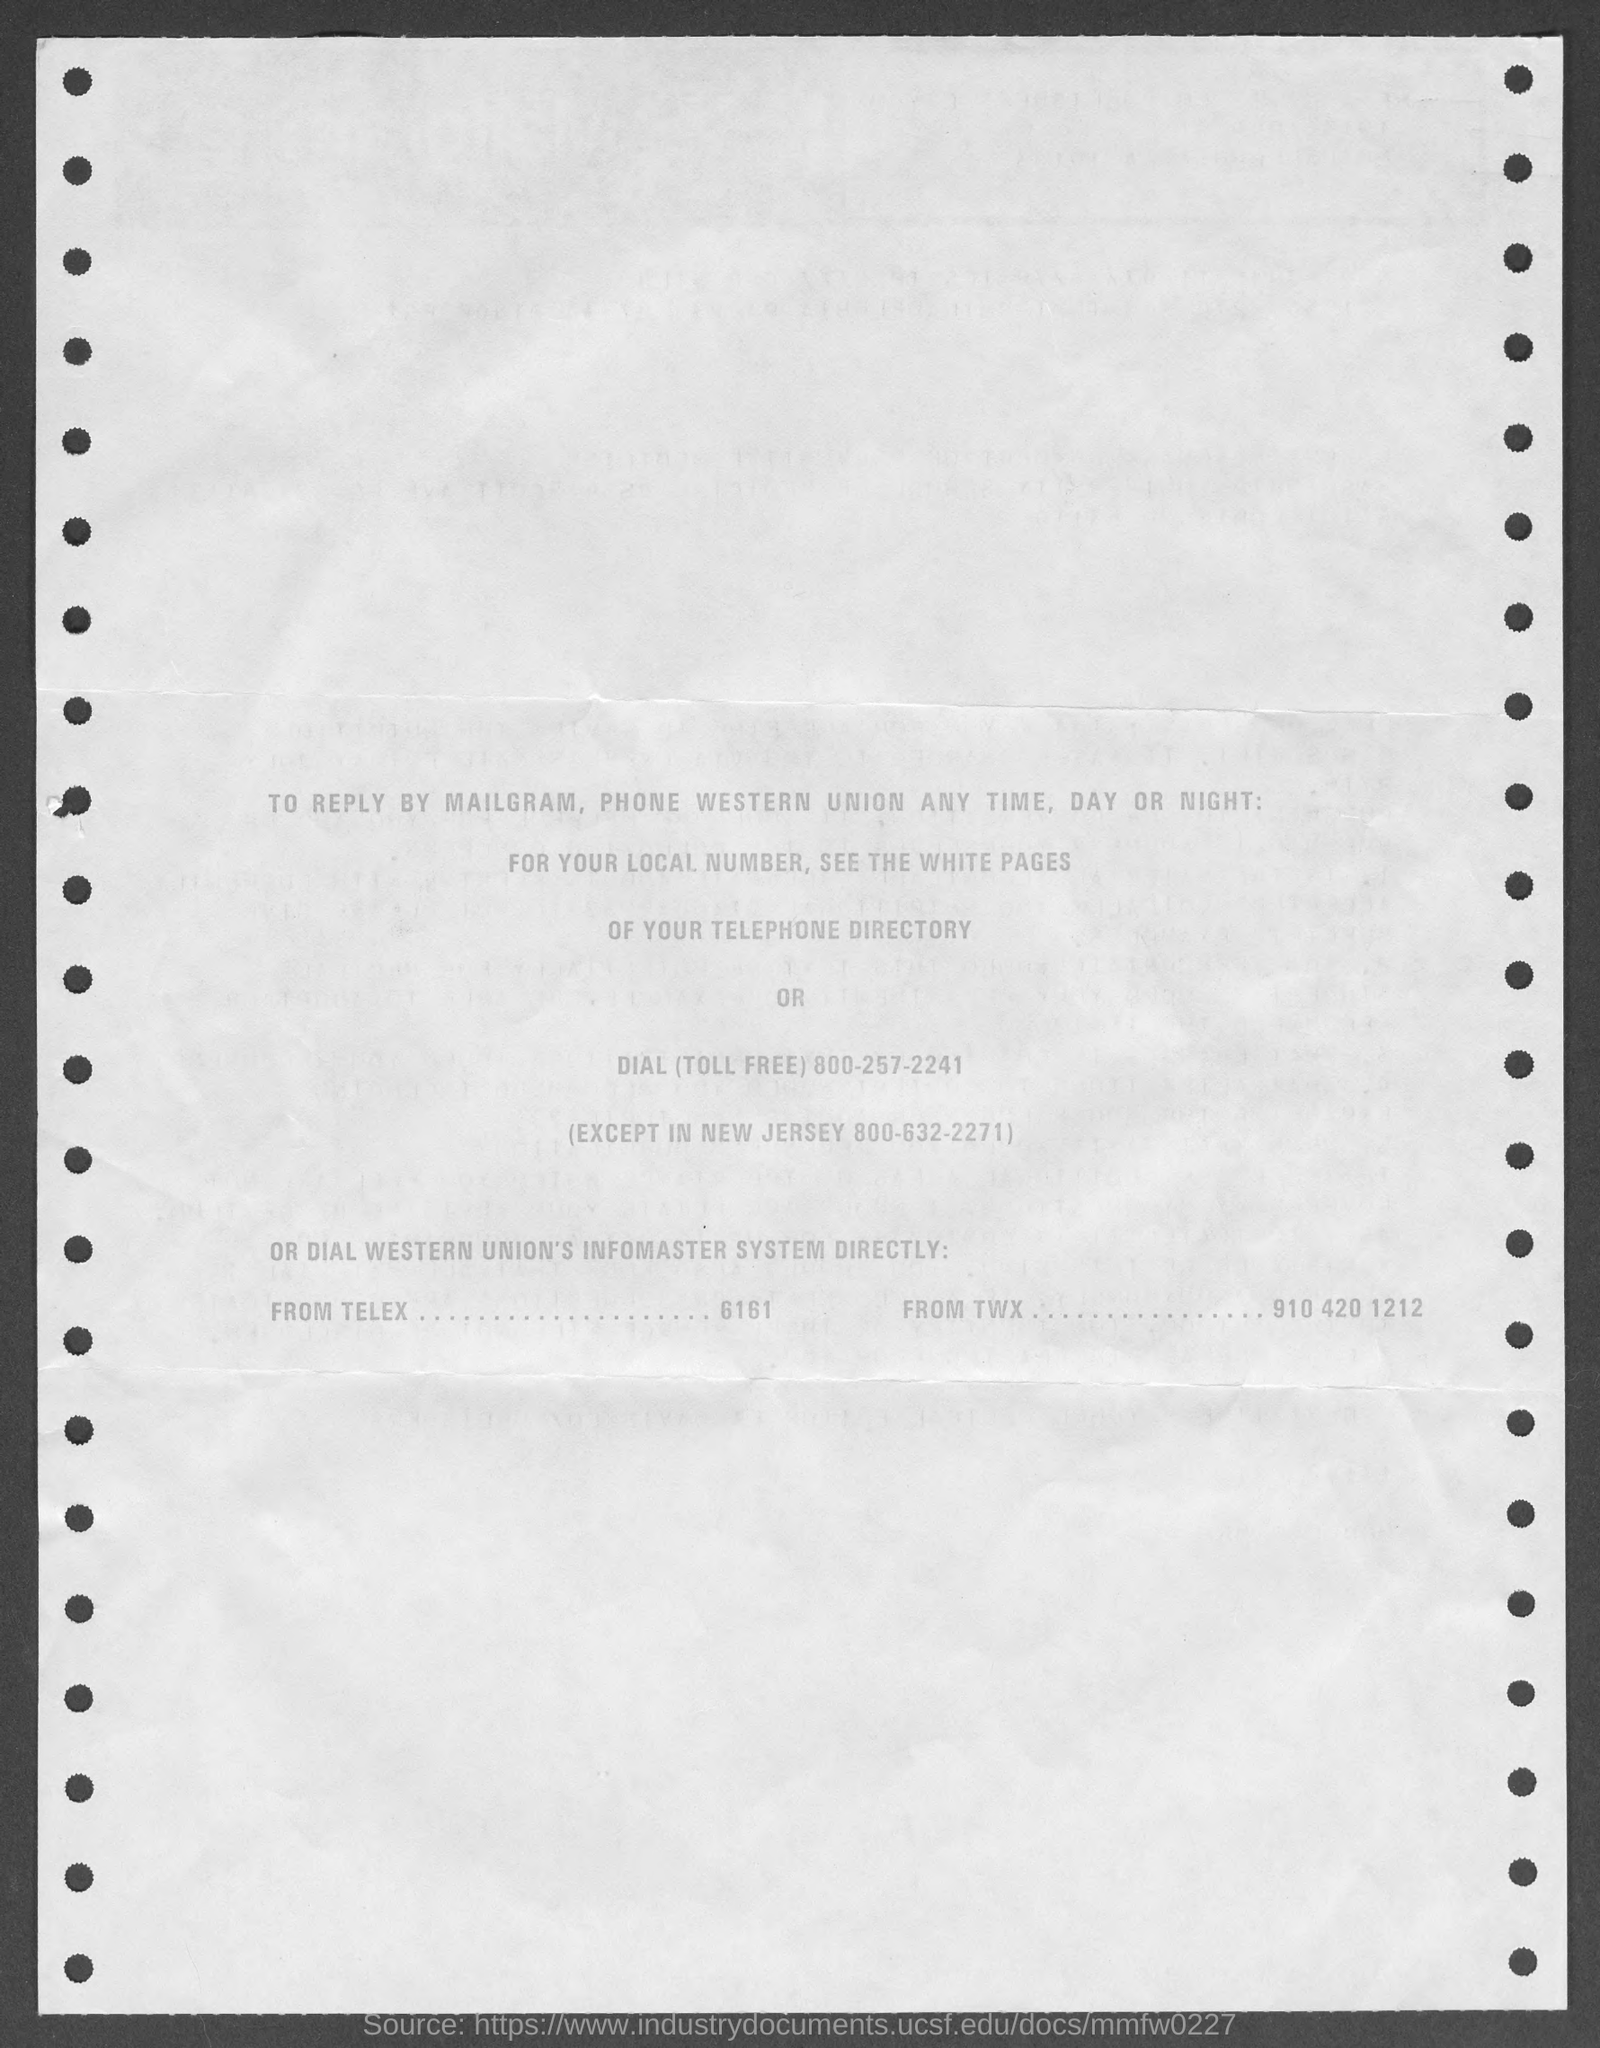Identify some key points in this picture. The toll-free number mentioned is 800-257-2241. The number for New Jersey is 800-632-2271. To locate the local number for your local number, please refer to the white pages of your telephone directory. 